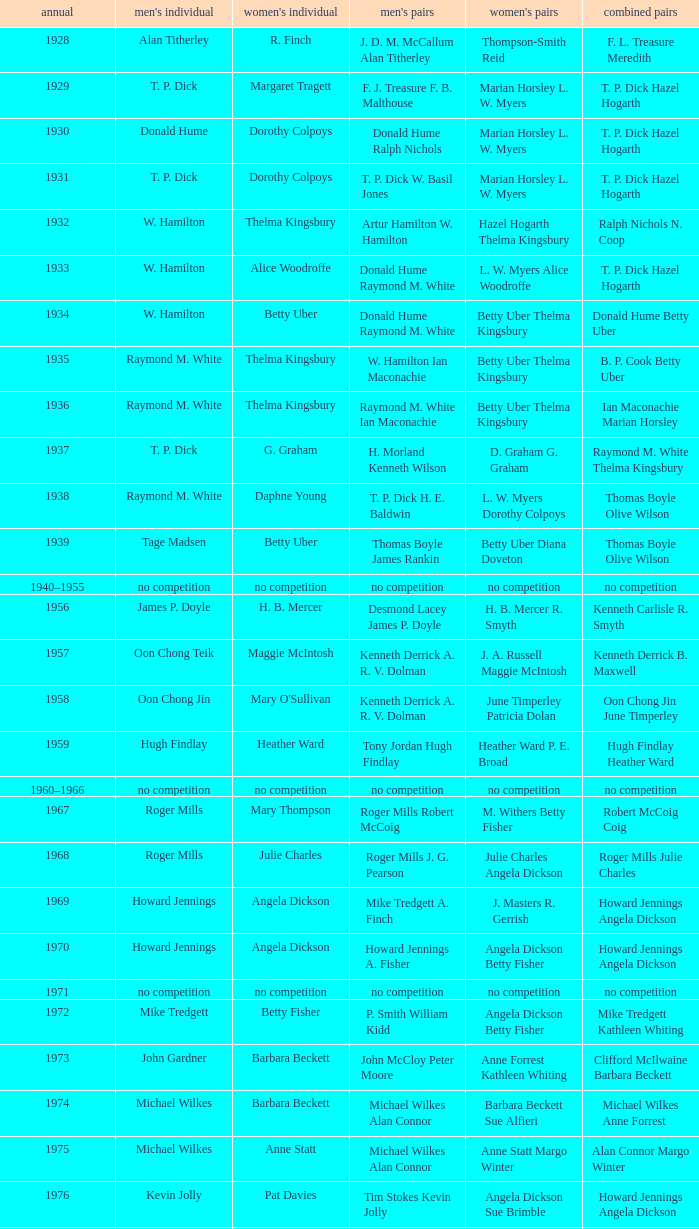Who won the Men's singles in the year that Ian Maconachie Marian Horsley won the Mixed doubles? Raymond M. White. 